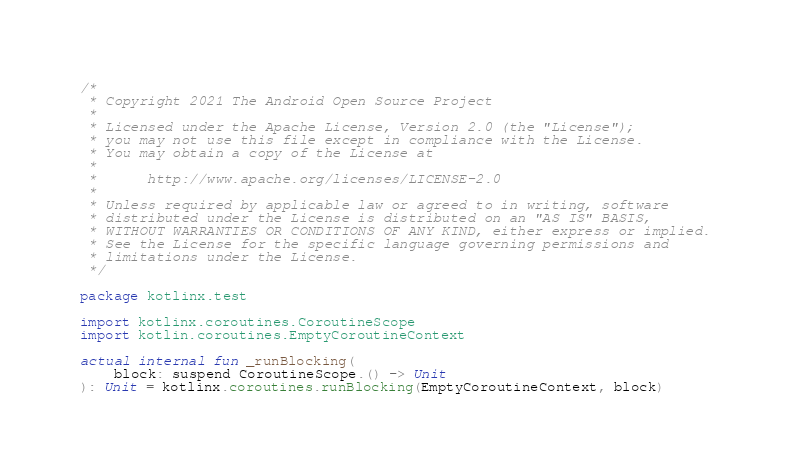Convert code to text. <code><loc_0><loc_0><loc_500><loc_500><_Kotlin_>/*
 * Copyright 2021 The Android Open Source Project
 *
 * Licensed under the Apache License, Version 2.0 (the "License");
 * you may not use this file except in compliance with the License.
 * You may obtain a copy of the License at
 *
 *      http://www.apache.org/licenses/LICENSE-2.0
 *
 * Unless required by applicable law or agreed to in writing, software
 * distributed under the License is distributed on an "AS IS" BASIS,
 * WITHOUT WARRANTIES OR CONDITIONS OF ANY KIND, either express or implied.
 * See the License for the specific language governing permissions and
 * limitations under the License.
 */

package kotlinx.test

import kotlinx.coroutines.CoroutineScope
import kotlin.coroutines.EmptyCoroutineContext

actual internal fun _runBlocking(
    block: suspend CoroutineScope.() -> Unit
): Unit = kotlinx.coroutines.runBlocking(EmptyCoroutineContext, block)</code> 